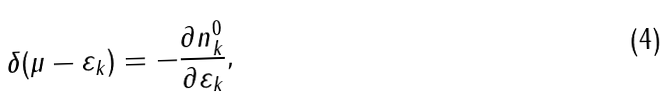<formula> <loc_0><loc_0><loc_500><loc_500>\delta ( \mu - \varepsilon _ { k } ) = - \frac { \partial n ^ { 0 } _ { k } } { \partial \varepsilon _ { k } } ,</formula> 